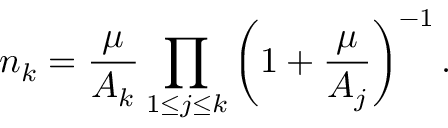Convert formula to latex. <formula><loc_0><loc_0><loc_500><loc_500>n _ { k } = \frac { \mu } { A _ { k } } \prod _ { 1 \leq j \leq k } \left ( 1 + \frac { \mu } { A _ { j } } \right ) ^ { - 1 } .</formula> 